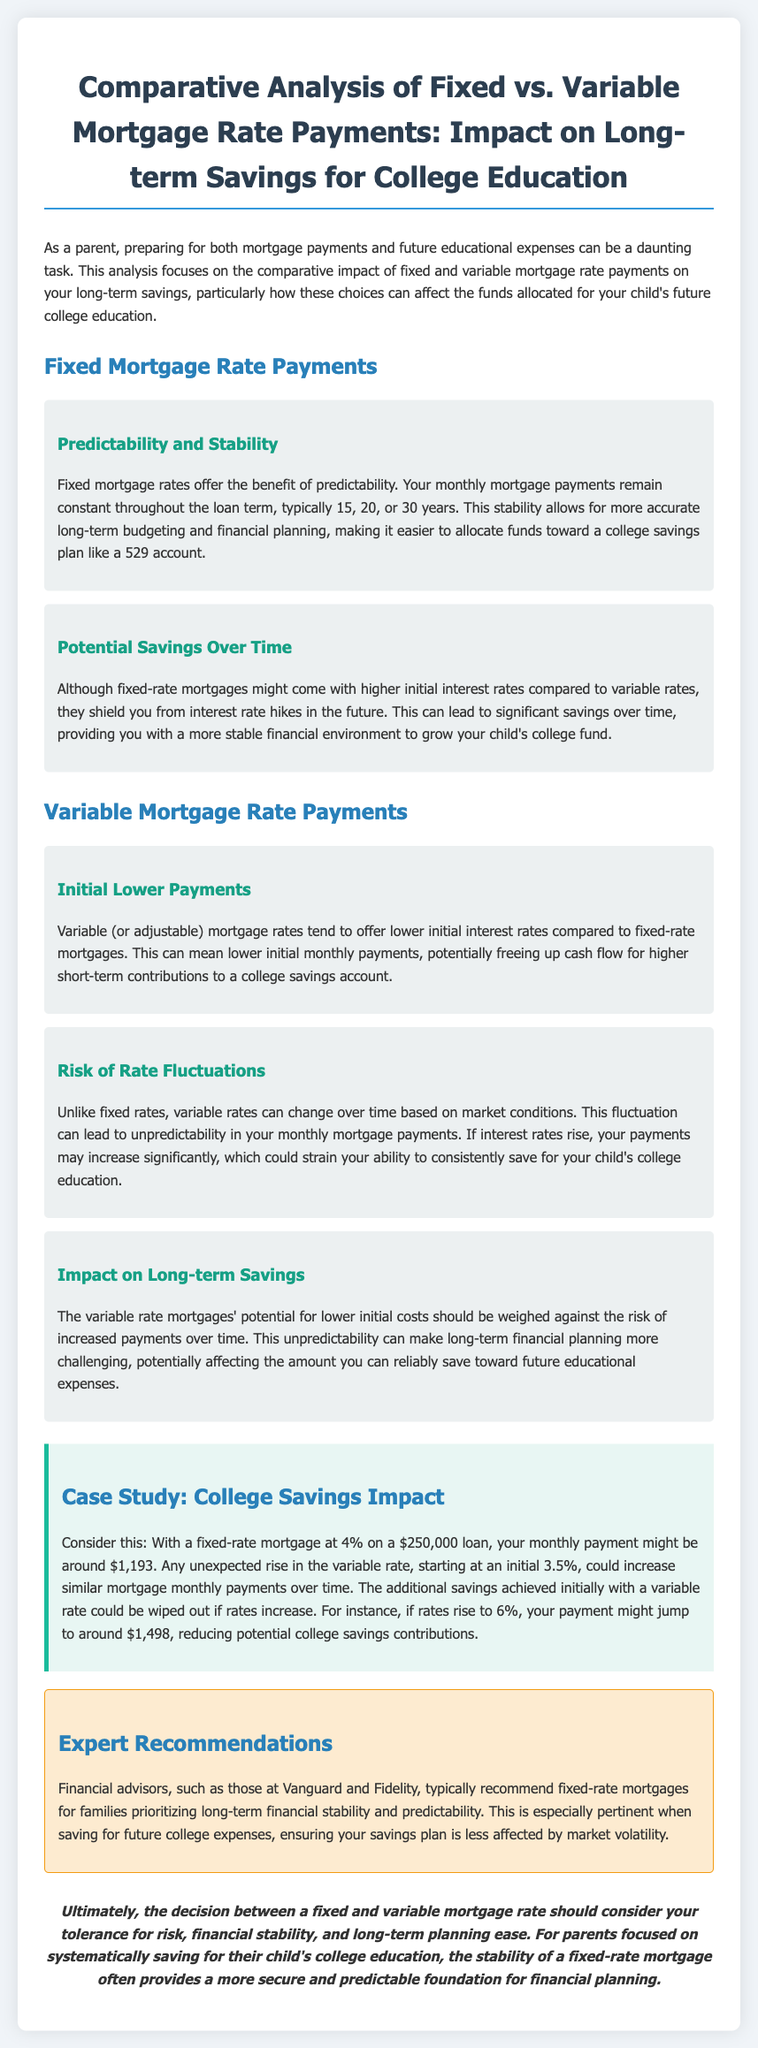what are the benefits of fixed mortgage rates? Fixed mortgage rates offer predictability and stability with constant payments, allowing for accurate long-term budgeting.
Answer: predictability and stability what is the initial interest rate for variable mortgage rates? Variable mortgage rates tend to offer lower initial interest rates compared to fixed-rate mortgages.
Answer: lower what can variable rates lead to over time? Variable rates can change over time based on market conditions, leading to unpredictability in monthly payments.
Answer: unpredictability what is the expert recommendation for families prioritizing long-term stability? Financial advisors typically recommend fixed-rate mortgages for families focused on long-term financial stability and predictability.
Answer: fixed-rate mortgages what is the monthly payment for a fixed-rate mortgage at 4% on a $250,000 loan? With a fixed-rate mortgage at 4%, the monthly payment for a $250,000 loan is approximately $1,193.
Answer: $1,193 what might happen if variable rates rise significantly? If interest rates rise significantly, your payments may increase, reducing potential college savings contributions.
Answer: payments may increase what type of document is this content representing? The content represents a comparative analysis of fixed vs. variable mortgage rates focusing on college savings.
Answer: comparative analysis 